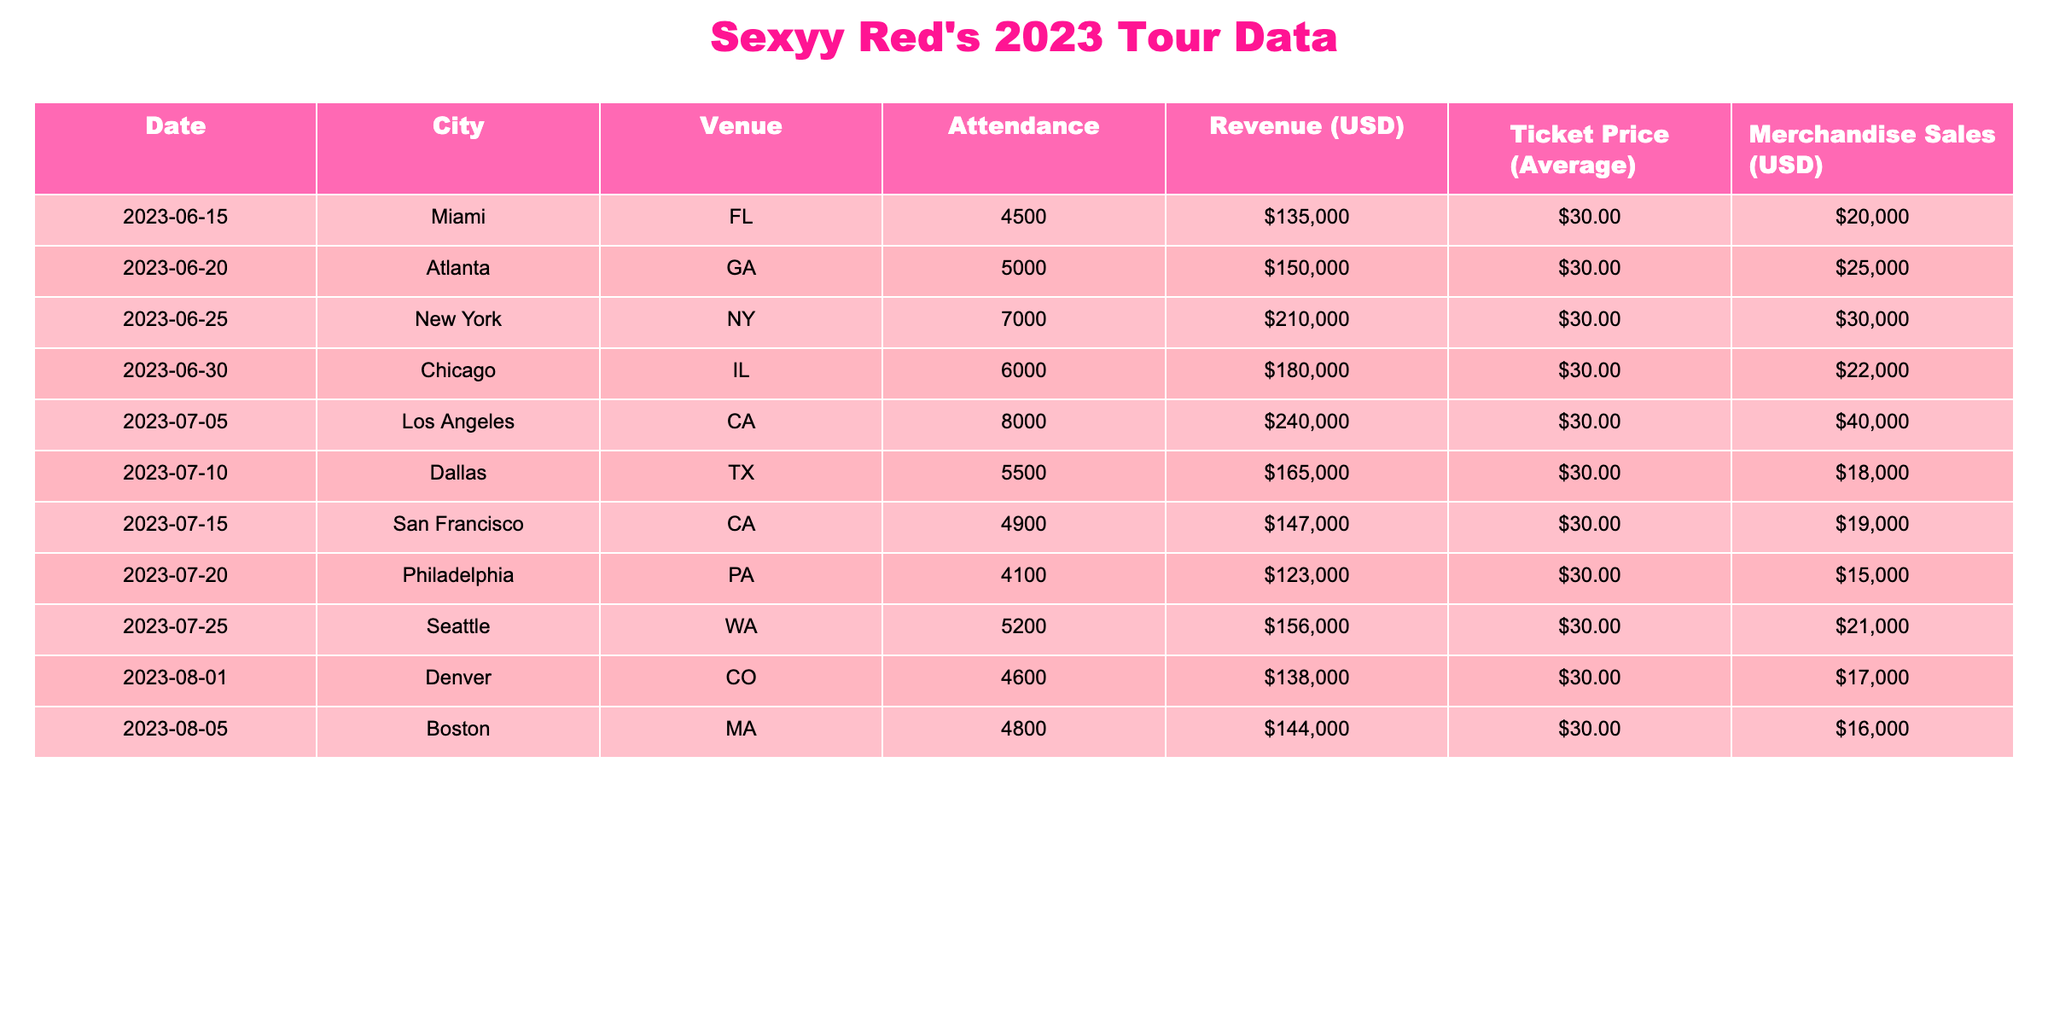What was the highest concert attendance during Sexyy Red's 2023 tour? Looking through the 'Attendance' column, the highest number is 8000, which occurred in Los Angeles on July 5th.
Answer: 8000 Which city had the lowest merchandise sales, and how much were they? By examining the 'Merchandise Sales' column, Philadelphia had the lowest sales at $15,000 on July 20th.
Answer: Philadelphia, $15,000 Calculate the total revenue generated from all tour dates. We sum up the revenue figures: 135000 + 150000 + 210000 + 180000 + 240000 + 165000 + 147000 + 123000 + 156000 + 138000 = 1,464,000.
Answer: $1,464,000 What is the average ticket price across all concerts? The average ticket price is consistently $30 for all concerts, as seen from the 'Ticket Price' column.
Answer: $30 Did all concerts have the same average ticket price? Yes, since the average ticket price is uniform at $30 across all the dates.
Answer: Yes Which concert had the highest merchandise sales, and how much was it? Reviewing the 'Merchandise Sales' column, the highest sales were from Los Angeles on July 5th, totaling $40,000.
Answer: Los Angeles, $40,000 What was the total attendance for Sexyy Red's concerts in June 2023? For June, the concert attendance figures are 4500 (Miami) and 5000 (Atlanta), totaling 4500 + 5000 = 9500.
Answer: 9500 Which date had a revenue figure closest to $150,000? Looking at the revenue figures, Atlanta on June 20th had a revenue of $150,000, which is exact.
Answer: June 20th, $150,000 If we compare Chicago and Dallas, which city had higher total revenue and by how much? Chicago's revenue was $180,000, and Dallas' was $165,000. The difference is 180000 - 165000 = $15,000, so Chicago was higher.
Answer: Chicago, $15,000 How many cities had concert attendance above 5000? The cities with attendance above 5000 are New York (7000), Los Angeles (8000), Chicago (6000), and Seattle (5200). There are four cities in total.
Answer: 4 